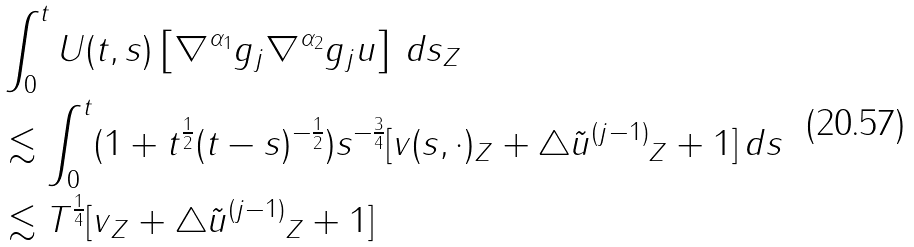<formula> <loc_0><loc_0><loc_500><loc_500>& \| \int _ { 0 } ^ { t } U ( t , s ) \left [ \nabla ^ { \alpha _ { 1 } } g _ { j } \nabla ^ { \alpha _ { 2 } } g _ { j } u \right ] \, d s \| _ { Z } \\ & \lesssim \int _ { 0 } ^ { t } ( 1 + t ^ { \frac { 1 } { 2 } } ( t - s ) ^ { - \frac { 1 } { 2 } } ) s ^ { - \frac { 3 } { 4 } } [ \| v ( s , \cdot ) \| _ { Z } + \| \triangle \tilde { u } ^ { ( j - 1 ) } \| _ { Z } + 1 ] \, d s \\ & \lesssim T ^ { \frac { 1 } { 4 } } [ \| v \| _ { Z } + \| \triangle \tilde { u } ^ { ( j - 1 ) } \| _ { Z } + 1 ]</formula> 